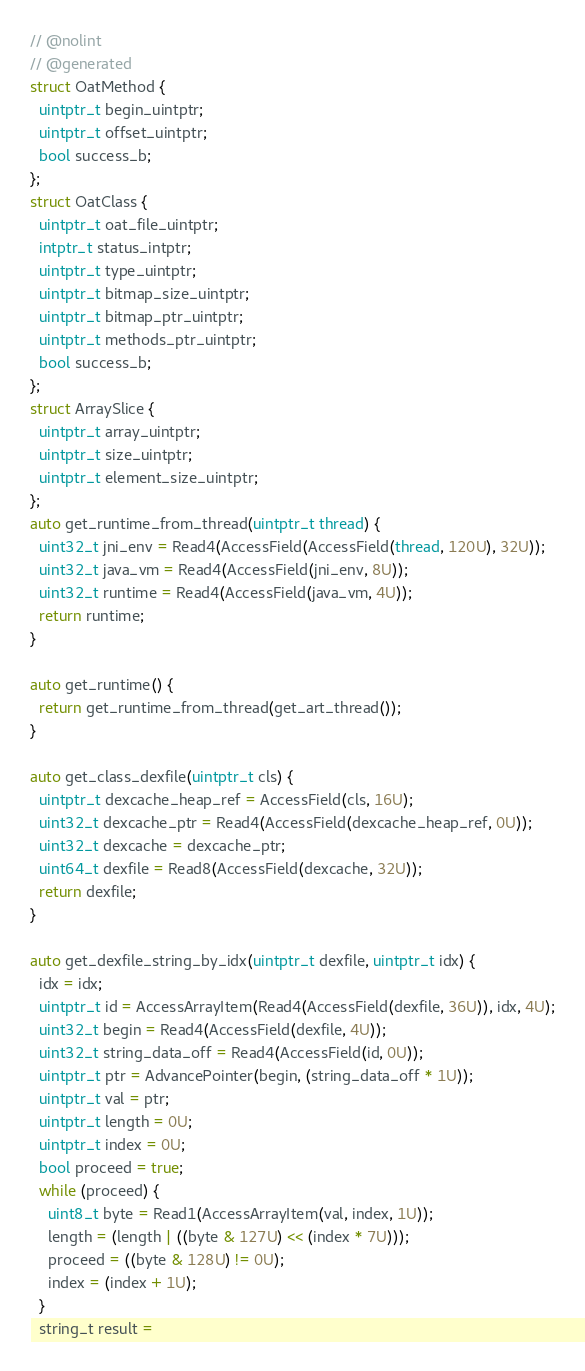<code> <loc_0><loc_0><loc_500><loc_500><_C_>// @nolint
// @generated
struct OatMethod {
  uintptr_t begin_uintptr;
  uintptr_t offset_uintptr;
  bool success_b;
};
struct OatClass {
  uintptr_t oat_file_uintptr;
  intptr_t status_intptr;
  uintptr_t type_uintptr;
  uintptr_t bitmap_size_uintptr;
  uintptr_t bitmap_ptr_uintptr;
  uintptr_t methods_ptr_uintptr;
  bool success_b;
};
struct ArraySlice {
  uintptr_t array_uintptr;
  uintptr_t size_uintptr;
  uintptr_t element_size_uintptr;
};
auto get_runtime_from_thread(uintptr_t thread) {
  uint32_t jni_env = Read4(AccessField(AccessField(thread, 120U), 32U));
  uint32_t java_vm = Read4(AccessField(jni_env, 8U));
  uint32_t runtime = Read4(AccessField(java_vm, 4U));
  return runtime;
}

auto get_runtime() {
  return get_runtime_from_thread(get_art_thread());
}

auto get_class_dexfile(uintptr_t cls) {
  uintptr_t dexcache_heap_ref = AccessField(cls, 16U);
  uint32_t dexcache_ptr = Read4(AccessField(dexcache_heap_ref, 0U));
  uint32_t dexcache = dexcache_ptr;
  uint64_t dexfile = Read8(AccessField(dexcache, 32U));
  return dexfile;
}

auto get_dexfile_string_by_idx(uintptr_t dexfile, uintptr_t idx) {
  idx = idx;
  uintptr_t id = AccessArrayItem(Read4(AccessField(dexfile, 36U)), idx, 4U);
  uint32_t begin = Read4(AccessField(dexfile, 4U));
  uint32_t string_data_off = Read4(AccessField(id, 0U));
  uintptr_t ptr = AdvancePointer(begin, (string_data_off * 1U));
  uintptr_t val = ptr;
  uintptr_t length = 0U;
  uintptr_t index = 0U;
  bool proceed = true;
  while (proceed) {
    uint8_t byte = Read1(AccessArrayItem(val, index, 1U));
    length = (length | ((byte & 127U) << (index * 7U)));
    proceed = ((byte & 128U) != 0U);
    index = (index + 1U);
  }
  string_t result =</code> 